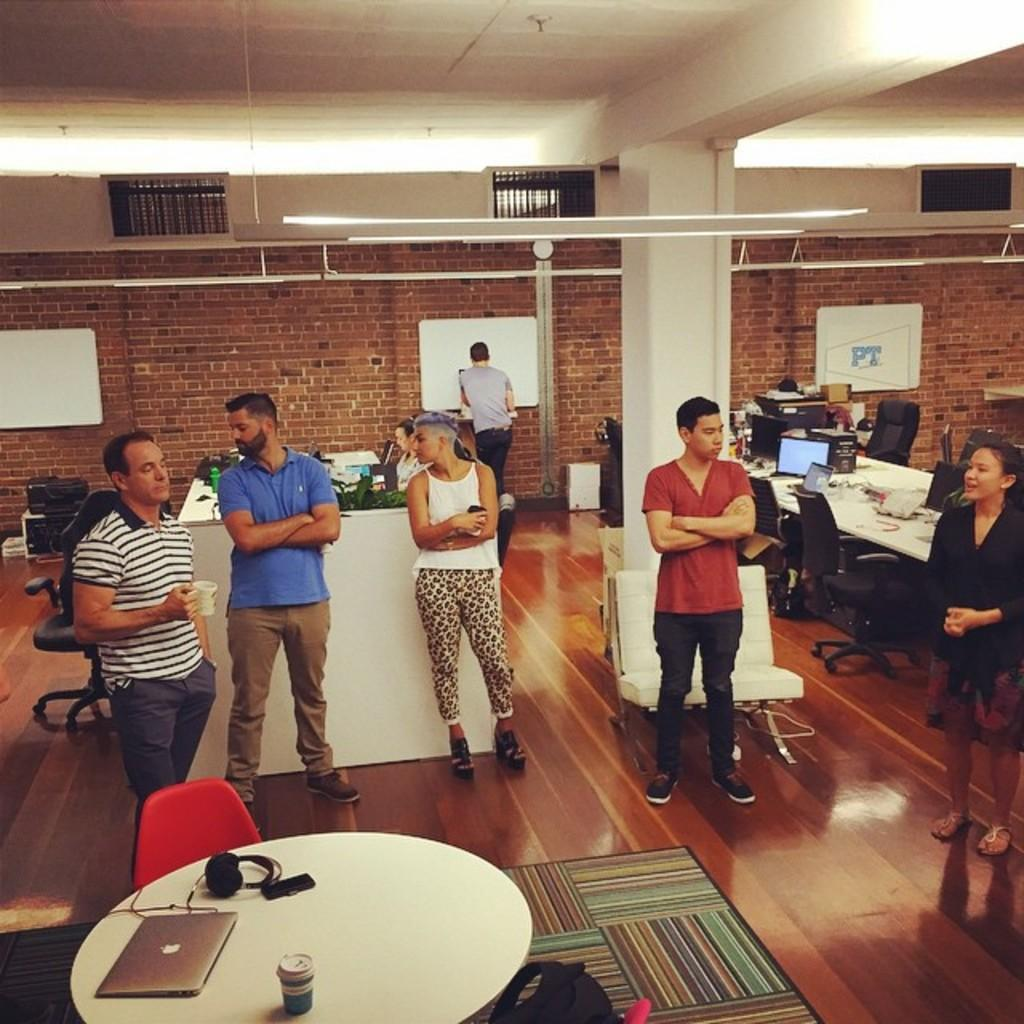What is the main activity of the people in the image? The people in the image are standing. What is the man holding in his hand? The man is holding a coffee mug in his hand. What electronic device is on the table? There is a laptop on the table. What other items are on the table? There are headphones and a mobile phone on the table. What type of business is the man conducting with his father and secretary in the image? There is no indication of a business, father, or secretary in the image; it only shows people standing, a man holding a coffee mug, and items on a table. 